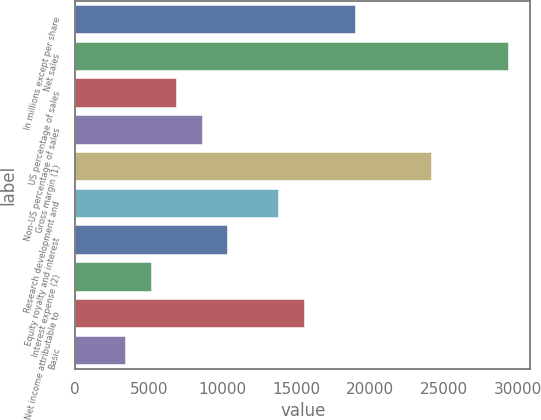<chart> <loc_0><loc_0><loc_500><loc_500><bar_chart><fcel>In millions except per share<fcel>Net sales<fcel>US percentage of sales<fcel>Non-US percentage of sales<fcel>Gross margin (1)<fcel>Research development and<fcel>Equity royalty and interest<fcel>Interest expense (2)<fcel>Net income attributable to<fcel>Basic<nl><fcel>19030.8<fcel>29410.1<fcel>6921.73<fcel>8651.6<fcel>24220.5<fcel>13841.2<fcel>10381.5<fcel>5191.86<fcel>15571.1<fcel>3461.99<nl></chart> 